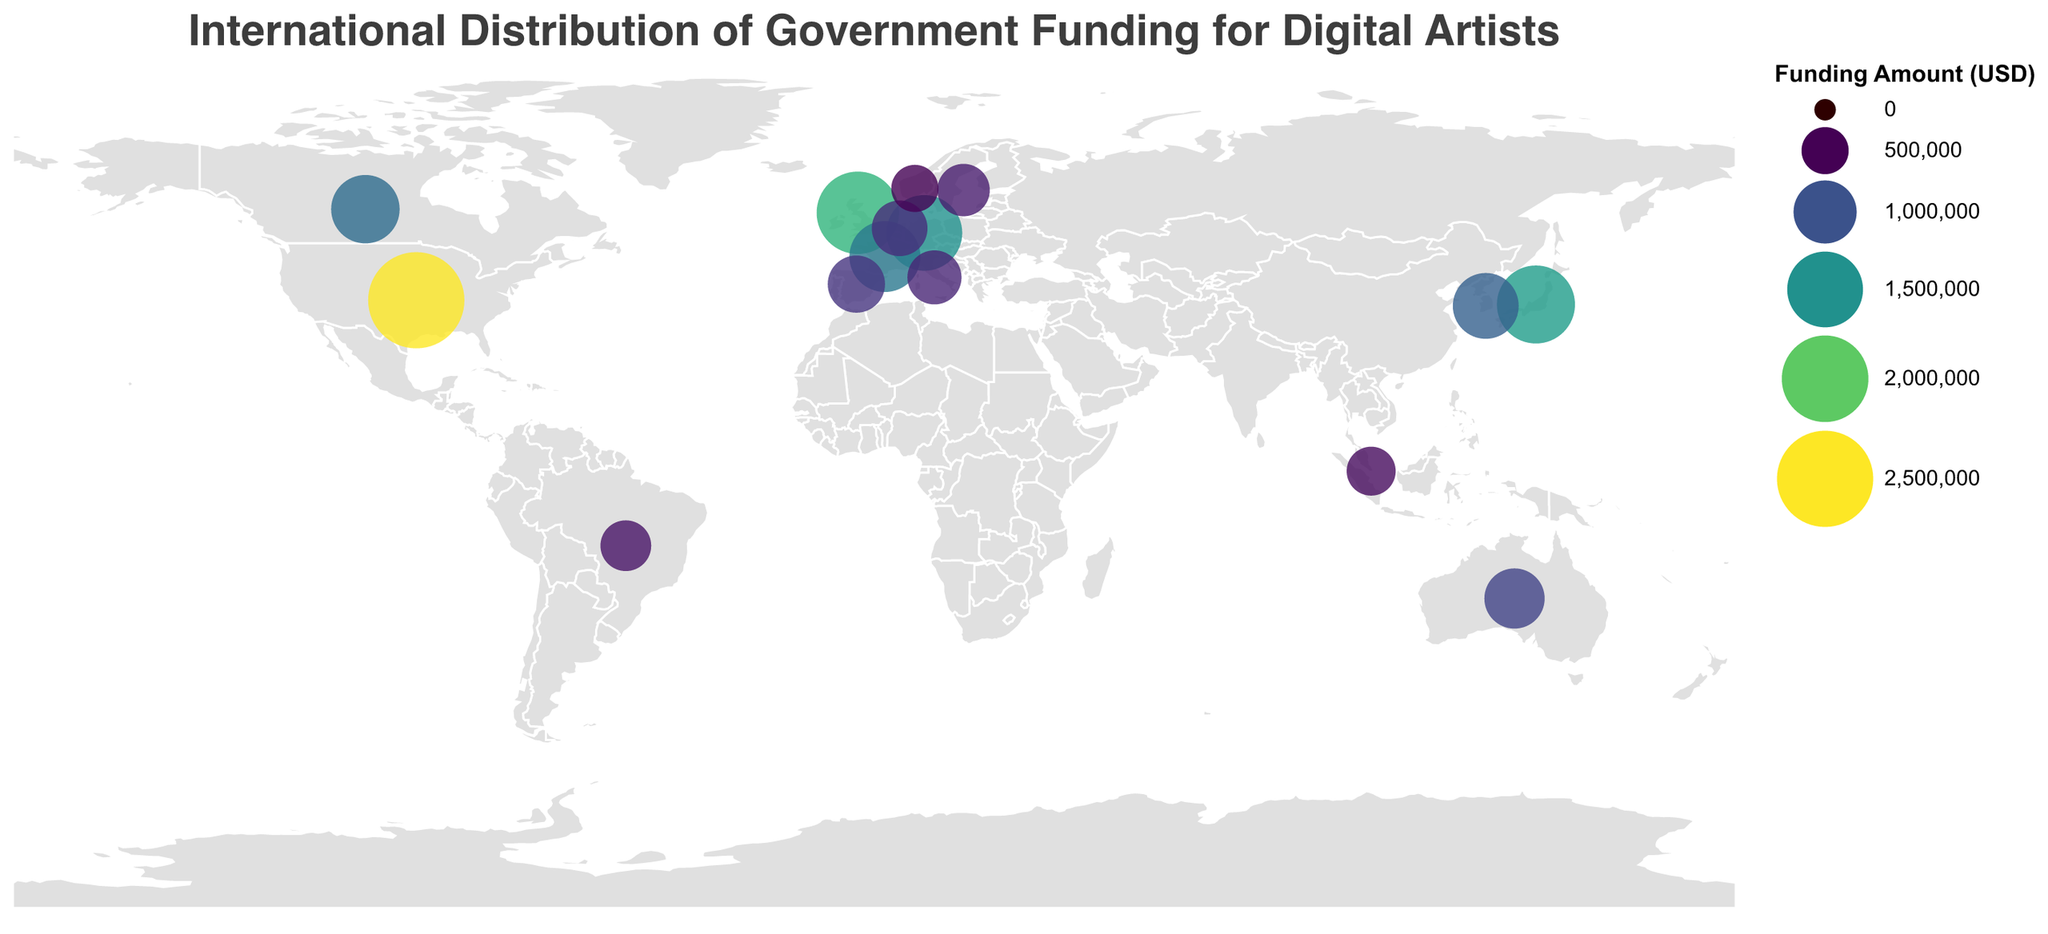What is the title of the figure? The title of the figure is usually displayed at the top. Here, the figure title is provided in the JSON code and it reads "International Distribution of Government Funding for Digital Artists".
Answer: International Distribution of Government Funding for Digital Artists Which country receives the highest amount of funding? To find the country with the highest funding, look for the largest circle in the figure or the tooltip with the highest number. According to the data, the United States receives the highest funding amount of $2,500,000.
Answer: United States How many countries are depicted receiving government funding for digital artists in this figure? Count the number of circles on the figure that represent different countries. The data lists 15 different countries receiving funding.
Answer: 15 Which two countries have the closest funding amounts? Compare amounts of funding for all countries and identify the closest values. Sweden ($650,000) and Netherlands ($750,000) have the smallest difference of $100,000 between them.
Answer: Sweden and Netherlands What is the total amount of government funding provided to the European countries depicted in the figure? Identify the European countries in the dataset (United Kingdom, Germany, France, Netherlands, Sweden, Spain, Italy, Norway). Sum up their respective funding amounts: $1,800,000 + $1,500,000 + $1,300,000 + $750,000 + $650,000 + $800,000 + $700,000 + $500,000 = $8,000,000.
Answer: $8,000,000 Which country receives more funding: Japan or Canada? Locate the funding amounts for Japan ($1,600,000) and Canada ($1,200,000). Compare the two values. Japan receives more funding.
Answer: Japan What is the average amount of funding received by the countries shown in the figure? Sum all of the funding amounts and divide by the number of countries. The total funding is $15,050,000 and there are 15 countries, so the average is $15,050,000 / 15 = $1,003,333.33.
Answer: $1,003,333.33 Which non-European country receives the least amount of funding? Focus on the non-European countries in the dataset (United States, Canada, Japan, Australia, South Korea, Brazil, Singapore). Compare their funding amounts and identify the smallest value. Singapore receives the least funding with $550,000.
Answer: Singapore 